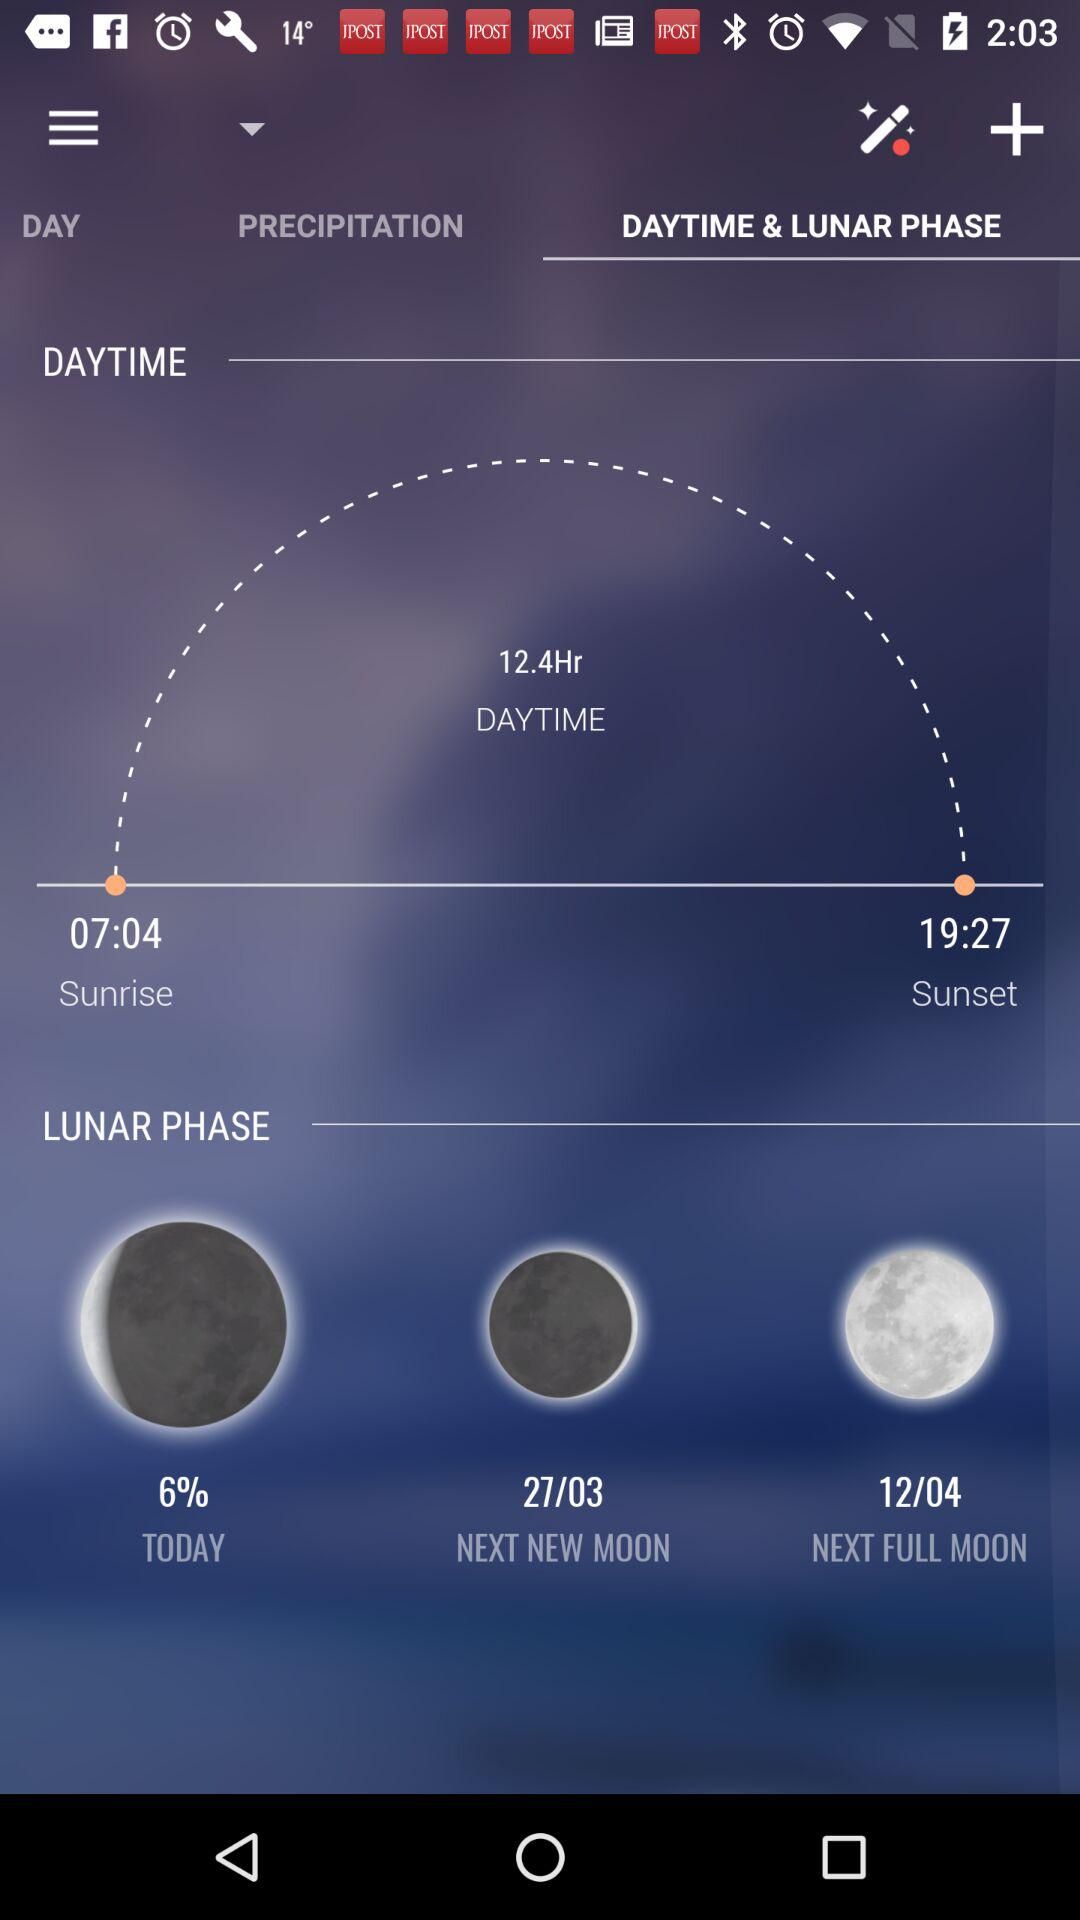How many hours are between sunrise and sunset?
Answer the question using a single word or phrase. 12.4 